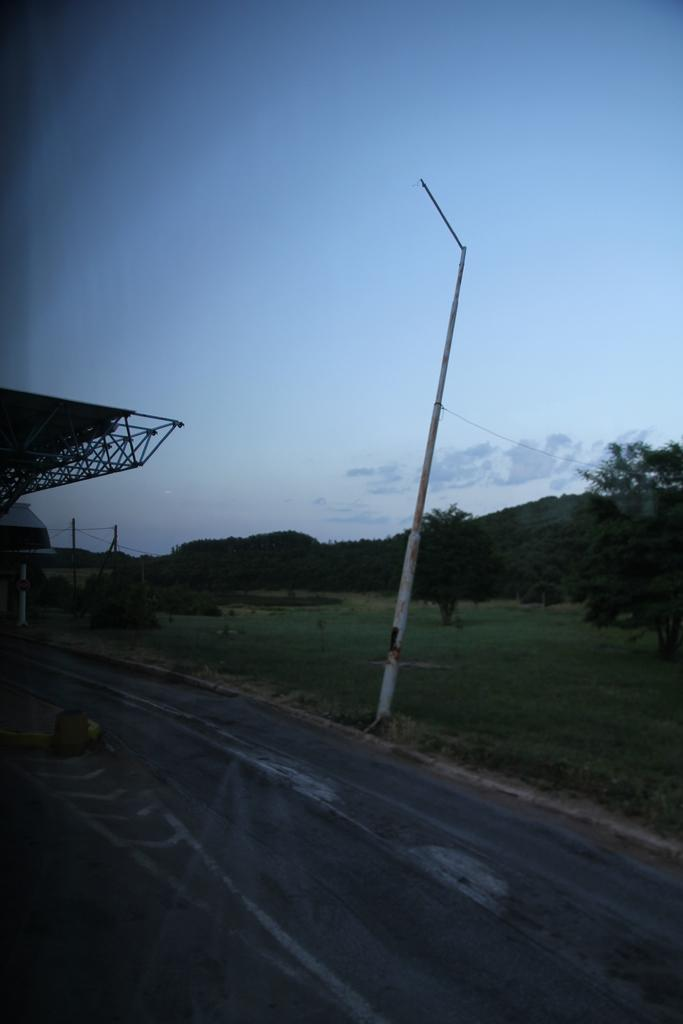What is: What is the main feature of the image? There is a road in the image. What can be seen on the right side of the image? There is green grass, trees, and a pole on the right side of the image. What is visible at the top of the image? The sky is visible at the top of the image. What type of roof is present on the left side of the image? There is a roof made up of metal rods on the left side of the image. How does the chicken contribute to the harmony in the image? There is no chicken present in the image, so it cannot contribute to the harmony. 